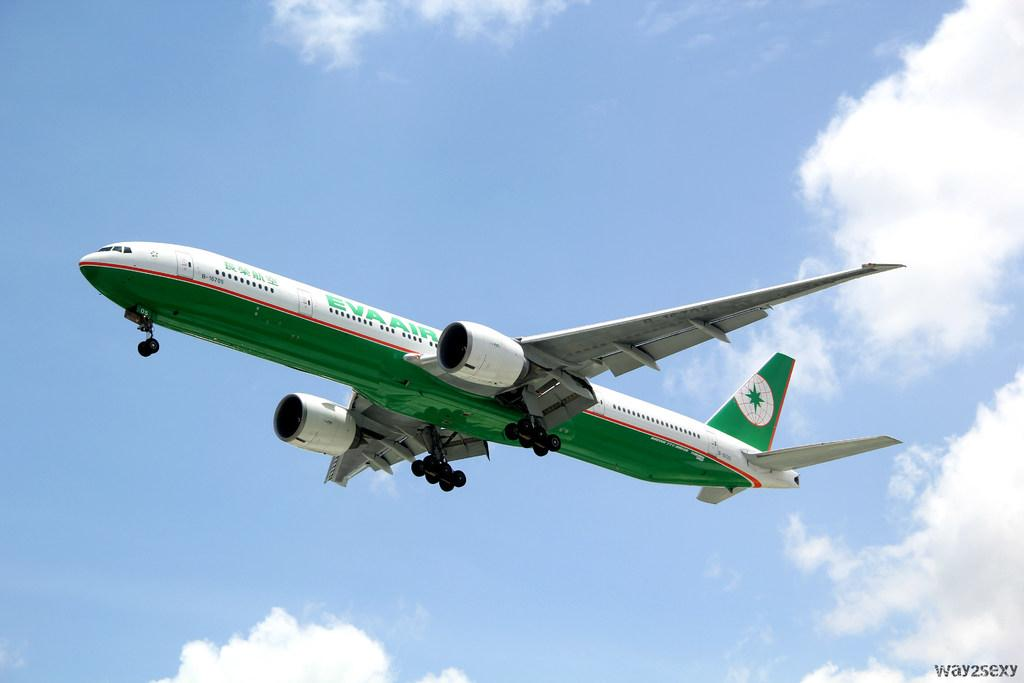What is the main subject of the image? There is an aeroplane in the center of the image. What can be seen in the background of the image? There is sky visible in the background of the image, and there are clouds present. What type of wound can be seen on the wing of the aeroplane in the image? There is no wound visible on the aeroplane in the image; it appears to be in good condition. 